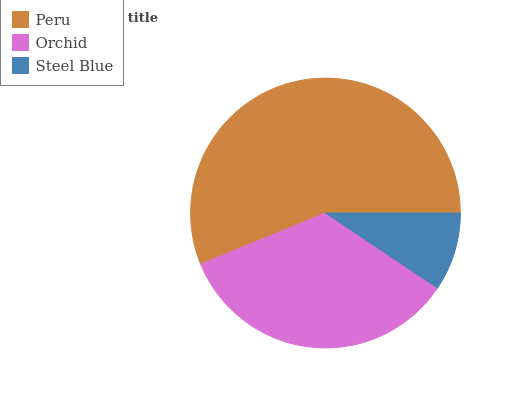Is Steel Blue the minimum?
Answer yes or no. Yes. Is Peru the maximum?
Answer yes or no. Yes. Is Orchid the minimum?
Answer yes or no. No. Is Orchid the maximum?
Answer yes or no. No. Is Peru greater than Orchid?
Answer yes or no. Yes. Is Orchid less than Peru?
Answer yes or no. Yes. Is Orchid greater than Peru?
Answer yes or no. No. Is Peru less than Orchid?
Answer yes or no. No. Is Orchid the high median?
Answer yes or no. Yes. Is Orchid the low median?
Answer yes or no. Yes. Is Peru the high median?
Answer yes or no. No. Is Peru the low median?
Answer yes or no. No. 